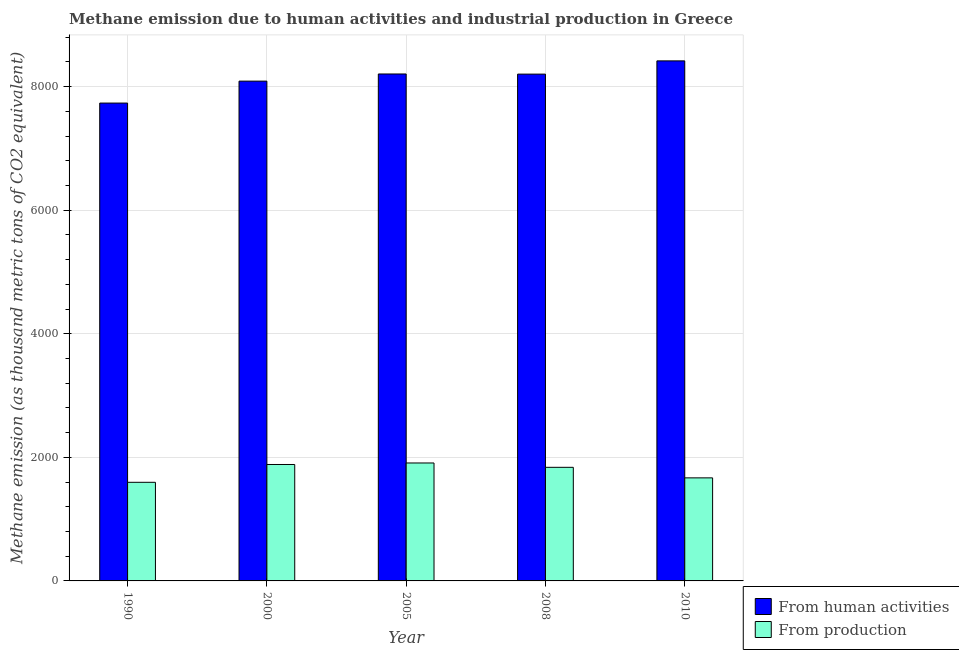How many groups of bars are there?
Your answer should be compact. 5. How many bars are there on the 5th tick from the left?
Provide a short and direct response. 2. What is the amount of emissions from human activities in 2005?
Provide a succinct answer. 8204.9. Across all years, what is the maximum amount of emissions from human activities?
Make the answer very short. 8417. Across all years, what is the minimum amount of emissions generated from industries?
Offer a very short reply. 1596. In which year was the amount of emissions from human activities maximum?
Keep it short and to the point. 2010. What is the total amount of emissions generated from industries in the graph?
Provide a succinct answer. 8895.8. What is the difference between the amount of emissions generated from industries in 2000 and that in 2005?
Your answer should be compact. -24.6. What is the difference between the amount of emissions from human activities in 2000 and the amount of emissions generated from industries in 2010?
Offer a very short reply. -327.8. What is the average amount of emissions from human activities per year?
Offer a very short reply. 8129.56. In how many years, is the amount of emissions from human activities greater than 1200 thousand metric tons?
Ensure brevity in your answer.  5. What is the ratio of the amount of emissions from human activities in 1990 to that in 2005?
Give a very brief answer. 0.94. Is the amount of emissions from human activities in 1990 less than that in 2000?
Ensure brevity in your answer.  Yes. Is the difference between the amount of emissions from human activities in 2008 and 2010 greater than the difference between the amount of emissions generated from industries in 2008 and 2010?
Offer a very short reply. No. What is the difference between the highest and the second highest amount of emissions generated from industries?
Ensure brevity in your answer.  24.6. What is the difference between the highest and the lowest amount of emissions generated from industries?
Offer a terse response. 312.9. In how many years, is the amount of emissions generated from industries greater than the average amount of emissions generated from industries taken over all years?
Keep it short and to the point. 3. Is the sum of the amount of emissions generated from industries in 2005 and 2010 greater than the maximum amount of emissions from human activities across all years?
Keep it short and to the point. Yes. What does the 1st bar from the left in 2005 represents?
Provide a short and direct response. From human activities. What does the 2nd bar from the right in 2005 represents?
Provide a short and direct response. From human activities. How many bars are there?
Your answer should be compact. 10. Are all the bars in the graph horizontal?
Ensure brevity in your answer.  No. How are the legend labels stacked?
Your response must be concise. Vertical. What is the title of the graph?
Keep it short and to the point. Methane emission due to human activities and industrial production in Greece. Does "constant 2005 US$" appear as one of the legend labels in the graph?
Your answer should be compact. No. What is the label or title of the X-axis?
Offer a very short reply. Year. What is the label or title of the Y-axis?
Make the answer very short. Methane emission (as thousand metric tons of CO2 equivalent). What is the Methane emission (as thousand metric tons of CO2 equivalent) of From human activities in 1990?
Provide a short and direct response. 7734.1. What is the Methane emission (as thousand metric tons of CO2 equivalent) of From production in 1990?
Make the answer very short. 1596. What is the Methane emission (as thousand metric tons of CO2 equivalent) of From human activities in 2000?
Offer a very short reply. 8089.2. What is the Methane emission (as thousand metric tons of CO2 equivalent) in From production in 2000?
Your answer should be compact. 1884.3. What is the Methane emission (as thousand metric tons of CO2 equivalent) of From human activities in 2005?
Ensure brevity in your answer.  8204.9. What is the Methane emission (as thousand metric tons of CO2 equivalent) in From production in 2005?
Provide a short and direct response. 1908.9. What is the Methane emission (as thousand metric tons of CO2 equivalent) in From human activities in 2008?
Your answer should be compact. 8202.6. What is the Methane emission (as thousand metric tons of CO2 equivalent) in From production in 2008?
Offer a terse response. 1838.7. What is the Methane emission (as thousand metric tons of CO2 equivalent) of From human activities in 2010?
Your answer should be compact. 8417. What is the Methane emission (as thousand metric tons of CO2 equivalent) in From production in 2010?
Your answer should be compact. 1667.9. Across all years, what is the maximum Methane emission (as thousand metric tons of CO2 equivalent) of From human activities?
Provide a short and direct response. 8417. Across all years, what is the maximum Methane emission (as thousand metric tons of CO2 equivalent) in From production?
Offer a very short reply. 1908.9. Across all years, what is the minimum Methane emission (as thousand metric tons of CO2 equivalent) of From human activities?
Offer a very short reply. 7734.1. Across all years, what is the minimum Methane emission (as thousand metric tons of CO2 equivalent) of From production?
Your answer should be compact. 1596. What is the total Methane emission (as thousand metric tons of CO2 equivalent) in From human activities in the graph?
Ensure brevity in your answer.  4.06e+04. What is the total Methane emission (as thousand metric tons of CO2 equivalent) of From production in the graph?
Offer a terse response. 8895.8. What is the difference between the Methane emission (as thousand metric tons of CO2 equivalent) in From human activities in 1990 and that in 2000?
Provide a short and direct response. -355.1. What is the difference between the Methane emission (as thousand metric tons of CO2 equivalent) of From production in 1990 and that in 2000?
Your response must be concise. -288.3. What is the difference between the Methane emission (as thousand metric tons of CO2 equivalent) of From human activities in 1990 and that in 2005?
Offer a terse response. -470.8. What is the difference between the Methane emission (as thousand metric tons of CO2 equivalent) of From production in 1990 and that in 2005?
Ensure brevity in your answer.  -312.9. What is the difference between the Methane emission (as thousand metric tons of CO2 equivalent) of From human activities in 1990 and that in 2008?
Your response must be concise. -468.5. What is the difference between the Methane emission (as thousand metric tons of CO2 equivalent) of From production in 1990 and that in 2008?
Give a very brief answer. -242.7. What is the difference between the Methane emission (as thousand metric tons of CO2 equivalent) in From human activities in 1990 and that in 2010?
Offer a terse response. -682.9. What is the difference between the Methane emission (as thousand metric tons of CO2 equivalent) in From production in 1990 and that in 2010?
Your response must be concise. -71.9. What is the difference between the Methane emission (as thousand metric tons of CO2 equivalent) in From human activities in 2000 and that in 2005?
Your answer should be very brief. -115.7. What is the difference between the Methane emission (as thousand metric tons of CO2 equivalent) of From production in 2000 and that in 2005?
Offer a very short reply. -24.6. What is the difference between the Methane emission (as thousand metric tons of CO2 equivalent) in From human activities in 2000 and that in 2008?
Your response must be concise. -113.4. What is the difference between the Methane emission (as thousand metric tons of CO2 equivalent) in From production in 2000 and that in 2008?
Your response must be concise. 45.6. What is the difference between the Methane emission (as thousand metric tons of CO2 equivalent) of From human activities in 2000 and that in 2010?
Provide a succinct answer. -327.8. What is the difference between the Methane emission (as thousand metric tons of CO2 equivalent) in From production in 2000 and that in 2010?
Your answer should be very brief. 216.4. What is the difference between the Methane emission (as thousand metric tons of CO2 equivalent) of From production in 2005 and that in 2008?
Provide a short and direct response. 70.2. What is the difference between the Methane emission (as thousand metric tons of CO2 equivalent) in From human activities in 2005 and that in 2010?
Your answer should be compact. -212.1. What is the difference between the Methane emission (as thousand metric tons of CO2 equivalent) of From production in 2005 and that in 2010?
Make the answer very short. 241. What is the difference between the Methane emission (as thousand metric tons of CO2 equivalent) in From human activities in 2008 and that in 2010?
Offer a very short reply. -214.4. What is the difference between the Methane emission (as thousand metric tons of CO2 equivalent) of From production in 2008 and that in 2010?
Provide a short and direct response. 170.8. What is the difference between the Methane emission (as thousand metric tons of CO2 equivalent) in From human activities in 1990 and the Methane emission (as thousand metric tons of CO2 equivalent) in From production in 2000?
Your answer should be very brief. 5849.8. What is the difference between the Methane emission (as thousand metric tons of CO2 equivalent) of From human activities in 1990 and the Methane emission (as thousand metric tons of CO2 equivalent) of From production in 2005?
Your answer should be very brief. 5825.2. What is the difference between the Methane emission (as thousand metric tons of CO2 equivalent) of From human activities in 1990 and the Methane emission (as thousand metric tons of CO2 equivalent) of From production in 2008?
Give a very brief answer. 5895.4. What is the difference between the Methane emission (as thousand metric tons of CO2 equivalent) in From human activities in 1990 and the Methane emission (as thousand metric tons of CO2 equivalent) in From production in 2010?
Your response must be concise. 6066.2. What is the difference between the Methane emission (as thousand metric tons of CO2 equivalent) in From human activities in 2000 and the Methane emission (as thousand metric tons of CO2 equivalent) in From production in 2005?
Ensure brevity in your answer.  6180.3. What is the difference between the Methane emission (as thousand metric tons of CO2 equivalent) of From human activities in 2000 and the Methane emission (as thousand metric tons of CO2 equivalent) of From production in 2008?
Your answer should be compact. 6250.5. What is the difference between the Methane emission (as thousand metric tons of CO2 equivalent) in From human activities in 2000 and the Methane emission (as thousand metric tons of CO2 equivalent) in From production in 2010?
Give a very brief answer. 6421.3. What is the difference between the Methane emission (as thousand metric tons of CO2 equivalent) in From human activities in 2005 and the Methane emission (as thousand metric tons of CO2 equivalent) in From production in 2008?
Keep it short and to the point. 6366.2. What is the difference between the Methane emission (as thousand metric tons of CO2 equivalent) in From human activities in 2005 and the Methane emission (as thousand metric tons of CO2 equivalent) in From production in 2010?
Provide a succinct answer. 6537. What is the difference between the Methane emission (as thousand metric tons of CO2 equivalent) in From human activities in 2008 and the Methane emission (as thousand metric tons of CO2 equivalent) in From production in 2010?
Keep it short and to the point. 6534.7. What is the average Methane emission (as thousand metric tons of CO2 equivalent) in From human activities per year?
Offer a very short reply. 8129.56. What is the average Methane emission (as thousand metric tons of CO2 equivalent) of From production per year?
Give a very brief answer. 1779.16. In the year 1990, what is the difference between the Methane emission (as thousand metric tons of CO2 equivalent) of From human activities and Methane emission (as thousand metric tons of CO2 equivalent) of From production?
Make the answer very short. 6138.1. In the year 2000, what is the difference between the Methane emission (as thousand metric tons of CO2 equivalent) of From human activities and Methane emission (as thousand metric tons of CO2 equivalent) of From production?
Ensure brevity in your answer.  6204.9. In the year 2005, what is the difference between the Methane emission (as thousand metric tons of CO2 equivalent) in From human activities and Methane emission (as thousand metric tons of CO2 equivalent) in From production?
Make the answer very short. 6296. In the year 2008, what is the difference between the Methane emission (as thousand metric tons of CO2 equivalent) in From human activities and Methane emission (as thousand metric tons of CO2 equivalent) in From production?
Give a very brief answer. 6363.9. In the year 2010, what is the difference between the Methane emission (as thousand metric tons of CO2 equivalent) of From human activities and Methane emission (as thousand metric tons of CO2 equivalent) of From production?
Offer a terse response. 6749.1. What is the ratio of the Methane emission (as thousand metric tons of CO2 equivalent) in From human activities in 1990 to that in 2000?
Offer a very short reply. 0.96. What is the ratio of the Methane emission (as thousand metric tons of CO2 equivalent) in From production in 1990 to that in 2000?
Offer a very short reply. 0.85. What is the ratio of the Methane emission (as thousand metric tons of CO2 equivalent) of From human activities in 1990 to that in 2005?
Keep it short and to the point. 0.94. What is the ratio of the Methane emission (as thousand metric tons of CO2 equivalent) of From production in 1990 to that in 2005?
Provide a short and direct response. 0.84. What is the ratio of the Methane emission (as thousand metric tons of CO2 equivalent) in From human activities in 1990 to that in 2008?
Make the answer very short. 0.94. What is the ratio of the Methane emission (as thousand metric tons of CO2 equivalent) of From production in 1990 to that in 2008?
Make the answer very short. 0.87. What is the ratio of the Methane emission (as thousand metric tons of CO2 equivalent) in From human activities in 1990 to that in 2010?
Keep it short and to the point. 0.92. What is the ratio of the Methane emission (as thousand metric tons of CO2 equivalent) in From production in 1990 to that in 2010?
Give a very brief answer. 0.96. What is the ratio of the Methane emission (as thousand metric tons of CO2 equivalent) in From human activities in 2000 to that in 2005?
Make the answer very short. 0.99. What is the ratio of the Methane emission (as thousand metric tons of CO2 equivalent) of From production in 2000 to that in 2005?
Your response must be concise. 0.99. What is the ratio of the Methane emission (as thousand metric tons of CO2 equivalent) in From human activities in 2000 to that in 2008?
Your answer should be compact. 0.99. What is the ratio of the Methane emission (as thousand metric tons of CO2 equivalent) in From production in 2000 to that in 2008?
Offer a very short reply. 1.02. What is the ratio of the Methane emission (as thousand metric tons of CO2 equivalent) of From human activities in 2000 to that in 2010?
Your response must be concise. 0.96. What is the ratio of the Methane emission (as thousand metric tons of CO2 equivalent) of From production in 2000 to that in 2010?
Make the answer very short. 1.13. What is the ratio of the Methane emission (as thousand metric tons of CO2 equivalent) in From production in 2005 to that in 2008?
Ensure brevity in your answer.  1.04. What is the ratio of the Methane emission (as thousand metric tons of CO2 equivalent) of From human activities in 2005 to that in 2010?
Offer a very short reply. 0.97. What is the ratio of the Methane emission (as thousand metric tons of CO2 equivalent) of From production in 2005 to that in 2010?
Offer a very short reply. 1.14. What is the ratio of the Methane emission (as thousand metric tons of CO2 equivalent) of From human activities in 2008 to that in 2010?
Your answer should be very brief. 0.97. What is the ratio of the Methane emission (as thousand metric tons of CO2 equivalent) of From production in 2008 to that in 2010?
Make the answer very short. 1.1. What is the difference between the highest and the second highest Methane emission (as thousand metric tons of CO2 equivalent) in From human activities?
Ensure brevity in your answer.  212.1. What is the difference between the highest and the second highest Methane emission (as thousand metric tons of CO2 equivalent) of From production?
Offer a terse response. 24.6. What is the difference between the highest and the lowest Methane emission (as thousand metric tons of CO2 equivalent) in From human activities?
Make the answer very short. 682.9. What is the difference between the highest and the lowest Methane emission (as thousand metric tons of CO2 equivalent) of From production?
Your answer should be compact. 312.9. 